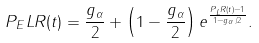Convert formula to latex. <formula><loc_0><loc_0><loc_500><loc_500>P _ { E } L R ( t ) = \frac { g _ { \alpha } } { 2 } + \left ( 1 - \frac { g _ { \alpha } } { 2 } \right ) e ^ { \frac { P _ { L } R ( t ) - 1 } { 1 - g _ { \alpha } / 2 } } .</formula> 